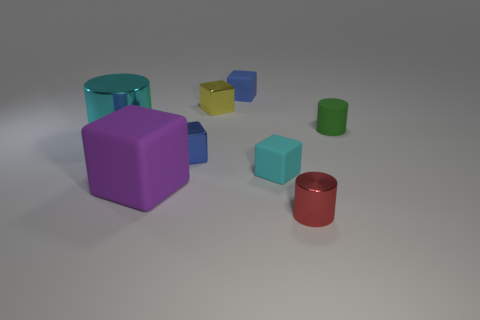Are there more tiny blue metal things behind the large cyan metallic cylinder than tiny yellow shiny blocks to the right of the small red shiny object?
Your answer should be very brief. No. There is a tiny green thing; does it have the same shape as the cyan thing on the left side of the small blue rubber thing?
Provide a short and direct response. Yes. What number of other objects are there of the same shape as the purple rubber object?
Offer a terse response. 4. There is a tiny metallic thing that is behind the tiny red object and in front of the small yellow metallic block; what color is it?
Your answer should be very brief. Blue. The matte cylinder is what color?
Give a very brief answer. Green. Does the small red cylinder have the same material as the tiny blue thing that is in front of the tiny yellow shiny object?
Give a very brief answer. Yes. There is a large object that is made of the same material as the small red cylinder; what is its shape?
Offer a very short reply. Cylinder. What is the color of the metallic cylinder that is the same size as the rubber cylinder?
Your answer should be compact. Red. There is a matte object that is right of the cyan block; is it the same size as the tiny red metallic cylinder?
Make the answer very short. Yes. How many tiny cylinders are there?
Your answer should be very brief. 2. 